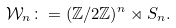Convert formula to latex. <formula><loc_0><loc_0><loc_500><loc_500>\mathcal { W } _ { n } \colon = ( \mathbb { Z } / 2 \mathbb { Z } ) ^ { n } \rtimes S _ { n } .</formula> 